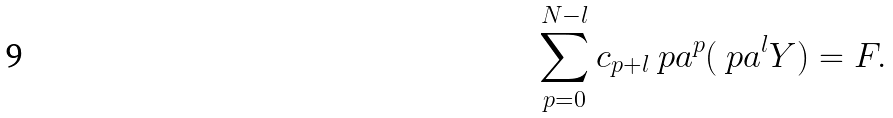Convert formula to latex. <formula><loc_0><loc_0><loc_500><loc_500>\sum _ { p = 0 } ^ { N - l } c _ { p + l } \ p a ^ { p } ( \ p a ^ { l } Y ) = F .</formula> 